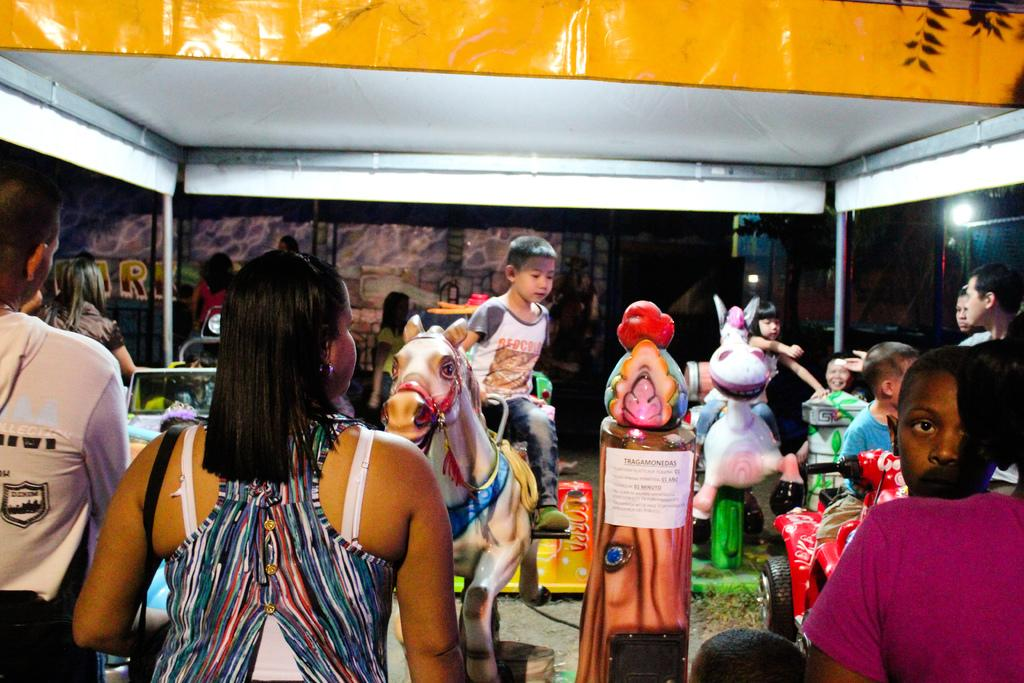What is happening in the image? There are people standing in the image, and a boy is sitting on a toy horse. Can you describe the boy's activity in the image? The boy is sitting on a toy horse. What type of produce is being harvested by the army in the image? There is no army or produce present in the image. The image only shows people standing and a boy sitting on a toy horse. 